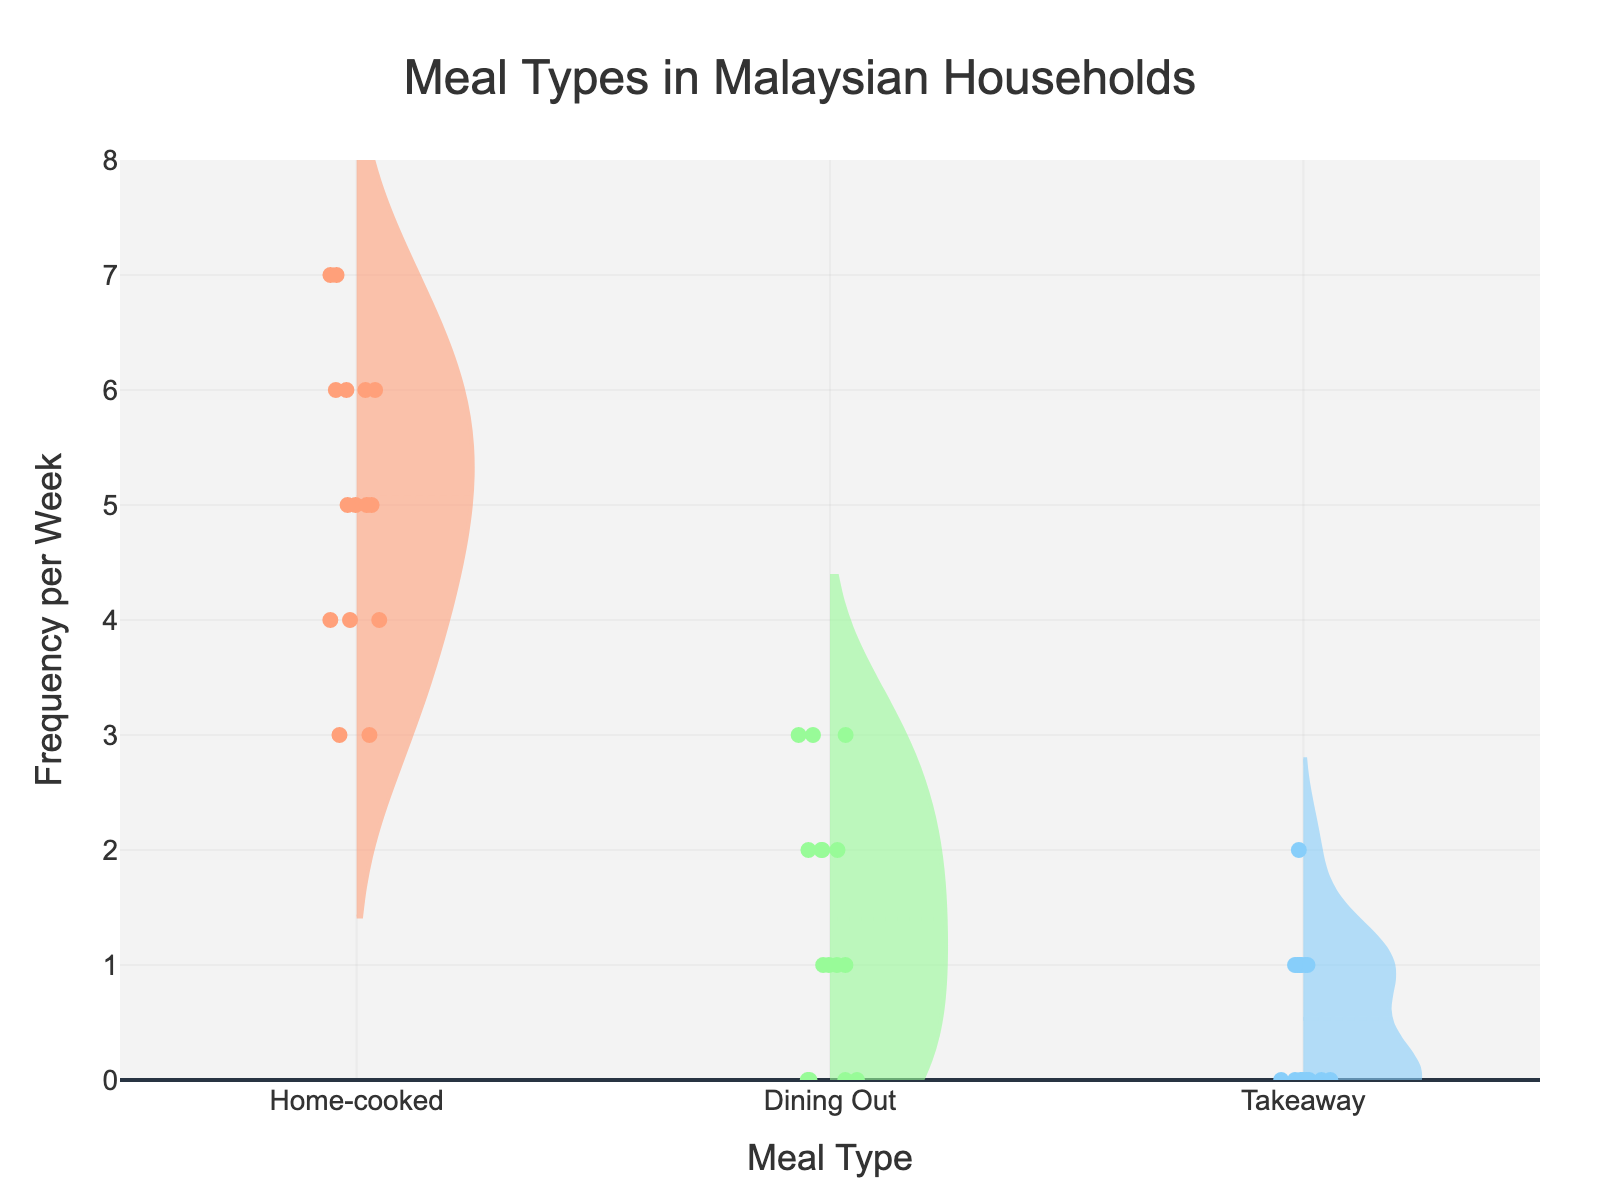What does the title of the figure say? The title is placed at the top center of the figure. It provides a brief description of what the figure is about. It reads "Meal Types in Malaysian Households".
Answer: Meal Types in Malaysian Households What are the three meal types shown in the figure? The figure has three distinct violin plots and box plots with labels. These labels indicate the meal types: Home-cooked, Dining Out, and Takeaway.
Answer: Home-cooked, Dining Out, Takeaway Which meal type shows the highest median frequency per week? To determine this, look at the median lines within the box plots. The meal type with the line positioned highest on the y-axis indicates the highest median. The Home-cooked meal type's box plot has the median line highest.
Answer: Home-cooked What is the range of frequencies for the Dining Out meal type? The range can be determined by looking at the spread of the Dining Out violin plot and the whiskers of its box plot. The lowest value starts from 0, and the highest value extends to 3.
Answer: 0 to 3 Which meal type has the most consistent frequency across households? Consistency can be inferred from the tightness of the violin plot and the range of the box plot. The Home-cooked meal type violin plot and box plot appear tightest, suggesting the most consistent frequency.
Answer: Home-cooked How do the Dinner Out and Takeaway meal types compare in terms of median frequency? By evaluating the median lines in both the Dining Out and Takeaway box plots, it's clear that the median line for Dining Out is higher compared to Takeaway.
Answer: Dining Out has a higher median frequency than Takeaway What is the interquartile range (IQR) for the Home-cooked meal type? The IQR is determined by the box in the box plot, indicating the range between the first and third quartiles. For Home-cooked, this box stretches from around 4 to 6, so 6 - 4 = 2.
Answer: 2 Which meal type appears to be the least frequent among Malaysian households? To determine the least frequent meal type, observe which violin plot has the lowest density and the lower median. Takeaway shows the lowest densities and medians compared to the other meal types.
Answer: Takeaway Are there any outliers in the frequencies for the Takeaway meal type? Outliers are typically indicated by points that are separate from the whiskers of the box plot. For Takeaway, the box plot does not show any such points, indicating no outliers.
Answer: No 